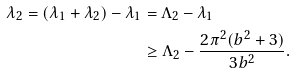<formula> <loc_0><loc_0><loc_500><loc_500>\lambda _ { 2 } = ( \lambda _ { 1 } + \lambda _ { 2 } ) - \lambda _ { 1 } & = \Lambda _ { 2 } - \lambda _ { 1 } \\ & \geq \Lambda _ { 2 } - \frac { 2 \pi ^ { 2 } ( b ^ { 2 } + 3 ) } { 3 b ^ { 2 } } .</formula> 